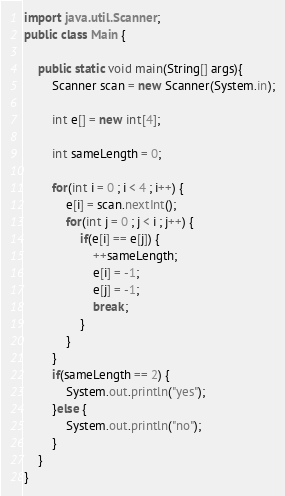<code> <loc_0><loc_0><loc_500><loc_500><_Java_>import java.util.Scanner;
public class Main {

	public static void main(String[] args){
		Scanner scan = new Scanner(System.in);
		
		int e[] = new int[4];
		
		int sameLength = 0;
		
		for(int i = 0 ; i < 4 ; i++) {
			e[i] = scan.nextInt();
			for(int j = 0 ; j < i ; j++) {
				if(e[i] == e[j]) {
					++sameLength;
					e[i] = -1;
					e[j] = -1;
					break;
				}
			}
		}
		if(sameLength == 2) {
			System.out.println("yes");
		}else {
			System.out.println("no");
		}
	}
}

</code> 